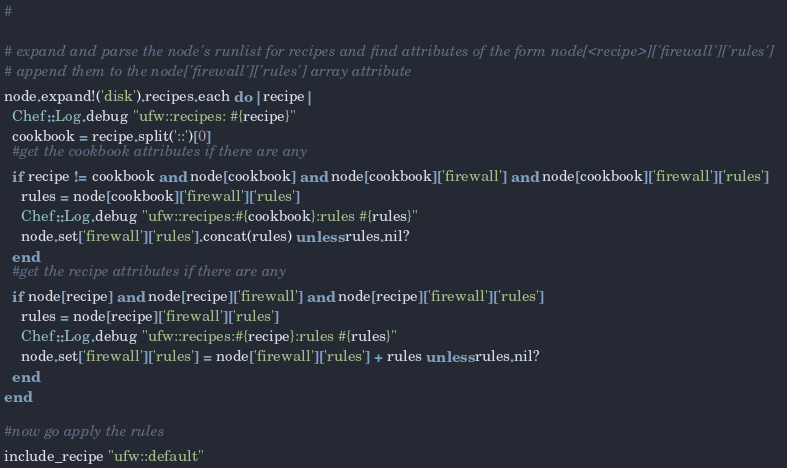<code> <loc_0><loc_0><loc_500><loc_500><_Ruby_>#

# expand and parse the node's runlist for recipes and find attributes of the form node[<recipe>]['firewall']['rules']
# append them to the node['firewall']['rules'] array attribute
node.expand!('disk').recipes.each do |recipe|
  Chef::Log.debug "ufw::recipes: #{recipe}"
  cookbook = recipe.split('::')[0]
  #get the cookbook attributes if there are any
  if recipe != cookbook and node[cookbook] and node[cookbook]['firewall'] and node[cookbook]['firewall']['rules']
    rules = node[cookbook]['firewall']['rules']
    Chef::Log.debug "ufw::recipes:#{cookbook}:rules #{rules}"
    node.set['firewall']['rules'].concat(rules) unless rules.nil?
  end
  #get the recipe attributes if there are any
  if node[recipe] and node[recipe]['firewall'] and node[recipe]['firewall']['rules']
    rules = node[recipe]['firewall']['rules']
    Chef::Log.debug "ufw::recipes:#{recipe}:rules #{rules}"
    node.set['firewall']['rules'] = node['firewall']['rules'] + rules unless rules.nil?
  end
end

#now go apply the rules
include_recipe "ufw::default"
</code> 